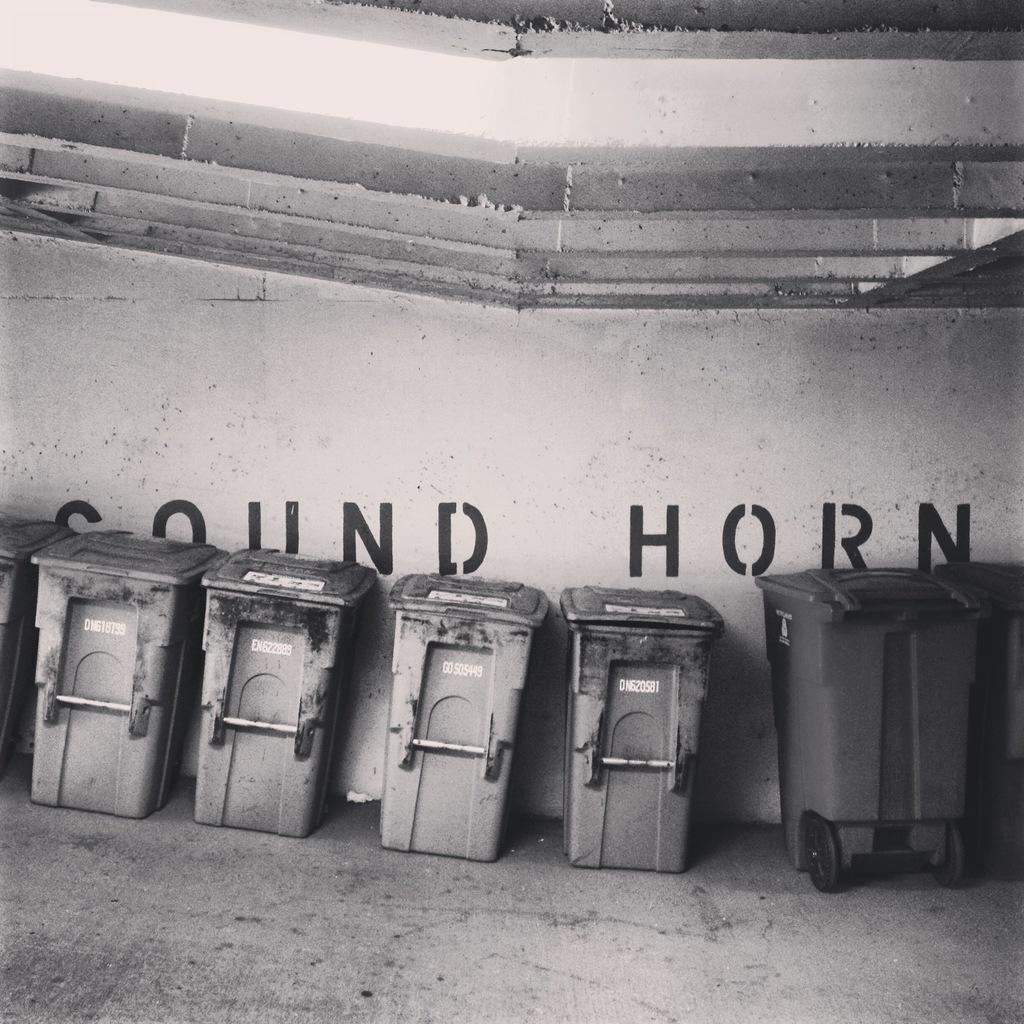<image>
Describe the image concisely. A sign on the wall behind some trash bins tells people to sound their horns. 